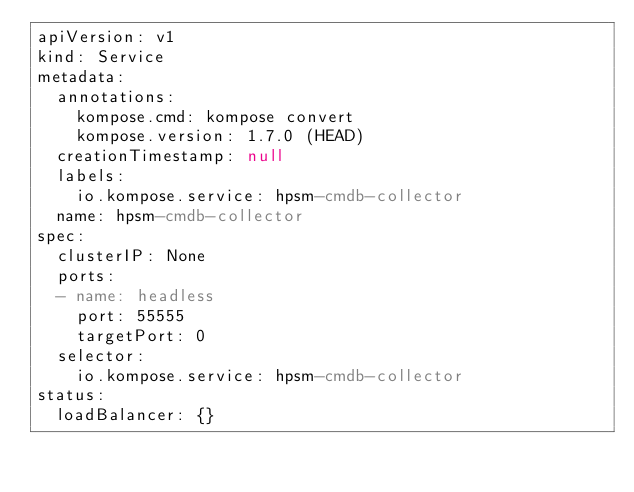<code> <loc_0><loc_0><loc_500><loc_500><_YAML_>apiVersion: v1
kind: Service
metadata:
  annotations:
    kompose.cmd: kompose convert
    kompose.version: 1.7.0 (HEAD)
  creationTimestamp: null
  labels:
    io.kompose.service: hpsm-cmdb-collector
  name: hpsm-cmdb-collector
spec:
  clusterIP: None
  ports:
  - name: headless
    port: 55555
    targetPort: 0
  selector:
    io.kompose.service: hpsm-cmdb-collector
status:
  loadBalancer: {}
</code> 